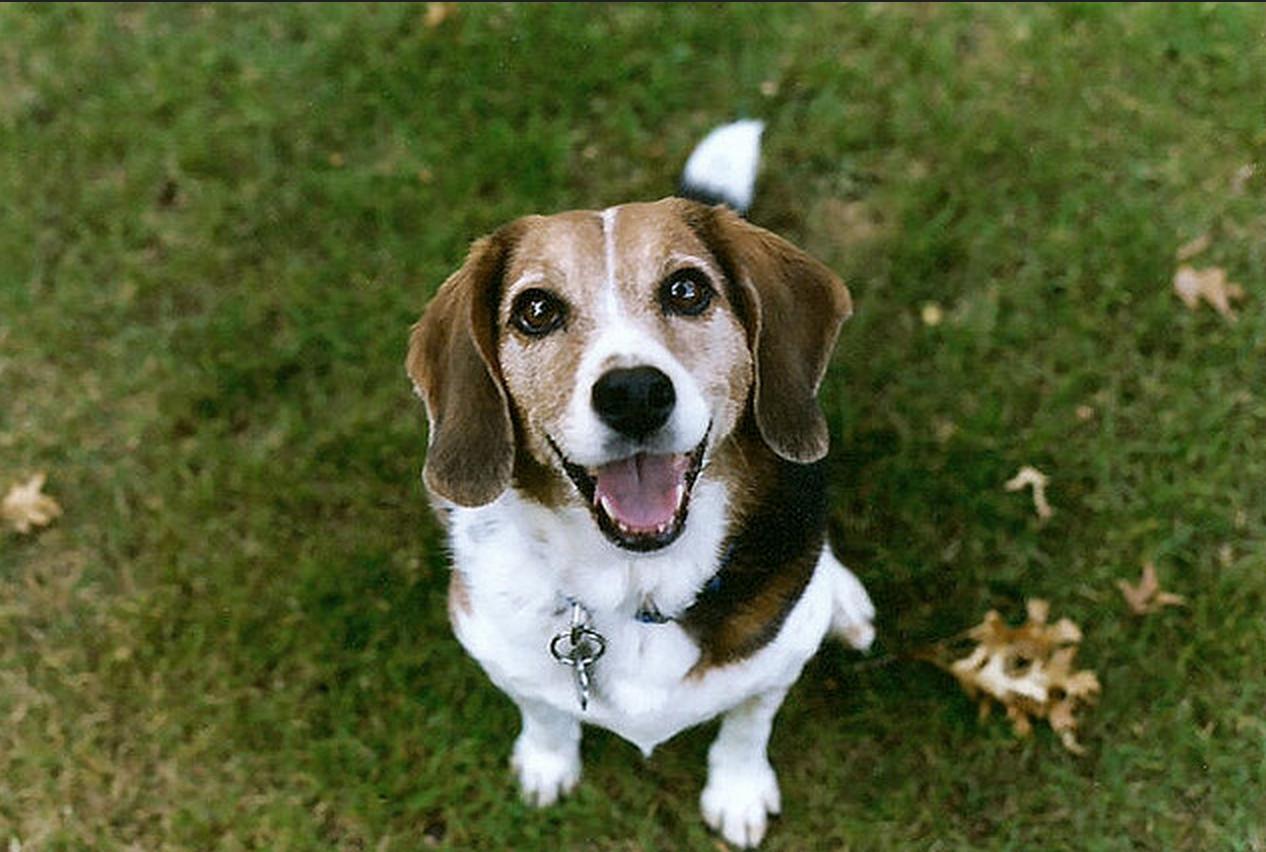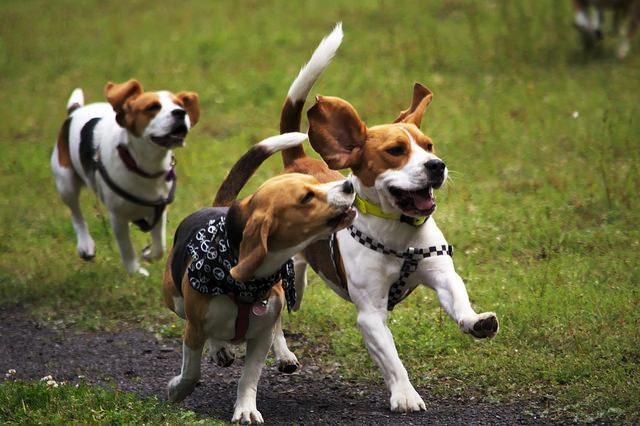The first image is the image on the left, the second image is the image on the right. For the images shown, is this caption "There are more dogs in the image on the right than on the left." true? Answer yes or no. Yes. The first image is the image on the left, the second image is the image on the right. Analyze the images presented: Is the assertion "The right image contains at least two dogs." valid? Answer yes or no. Yes. 